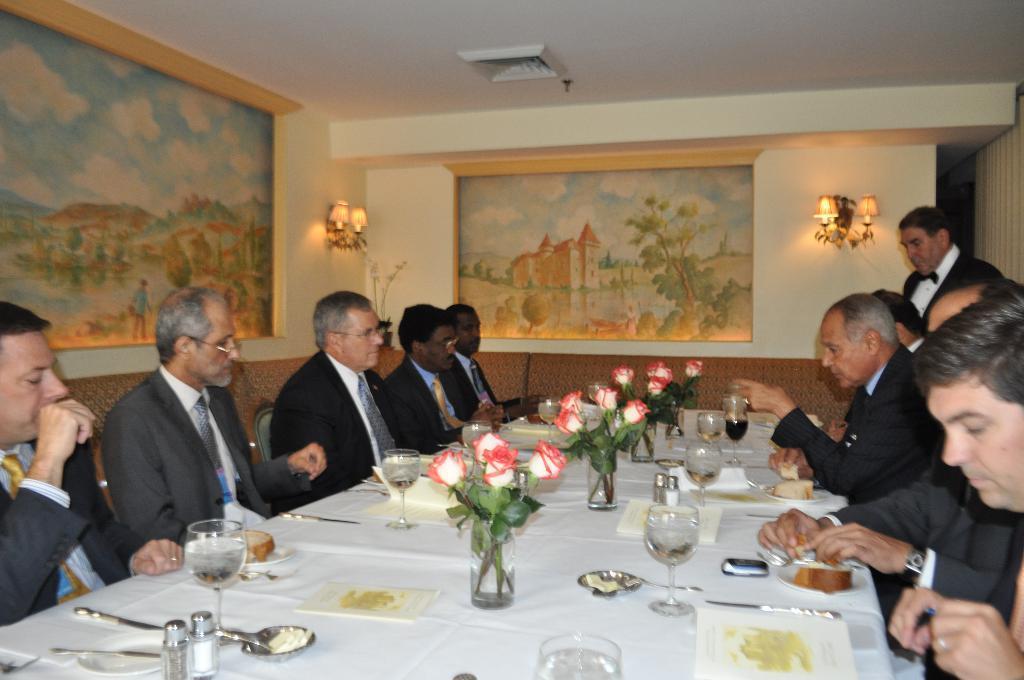Please provide a concise description of this image. In this image I can see group of people sitting on the chairs and one person is standing. In front of them there is a glass,flower vase,spoons on the table. To the wall there is a painting of trees,house,water,and the cloudy sky and also the lamp attached to the wall. 